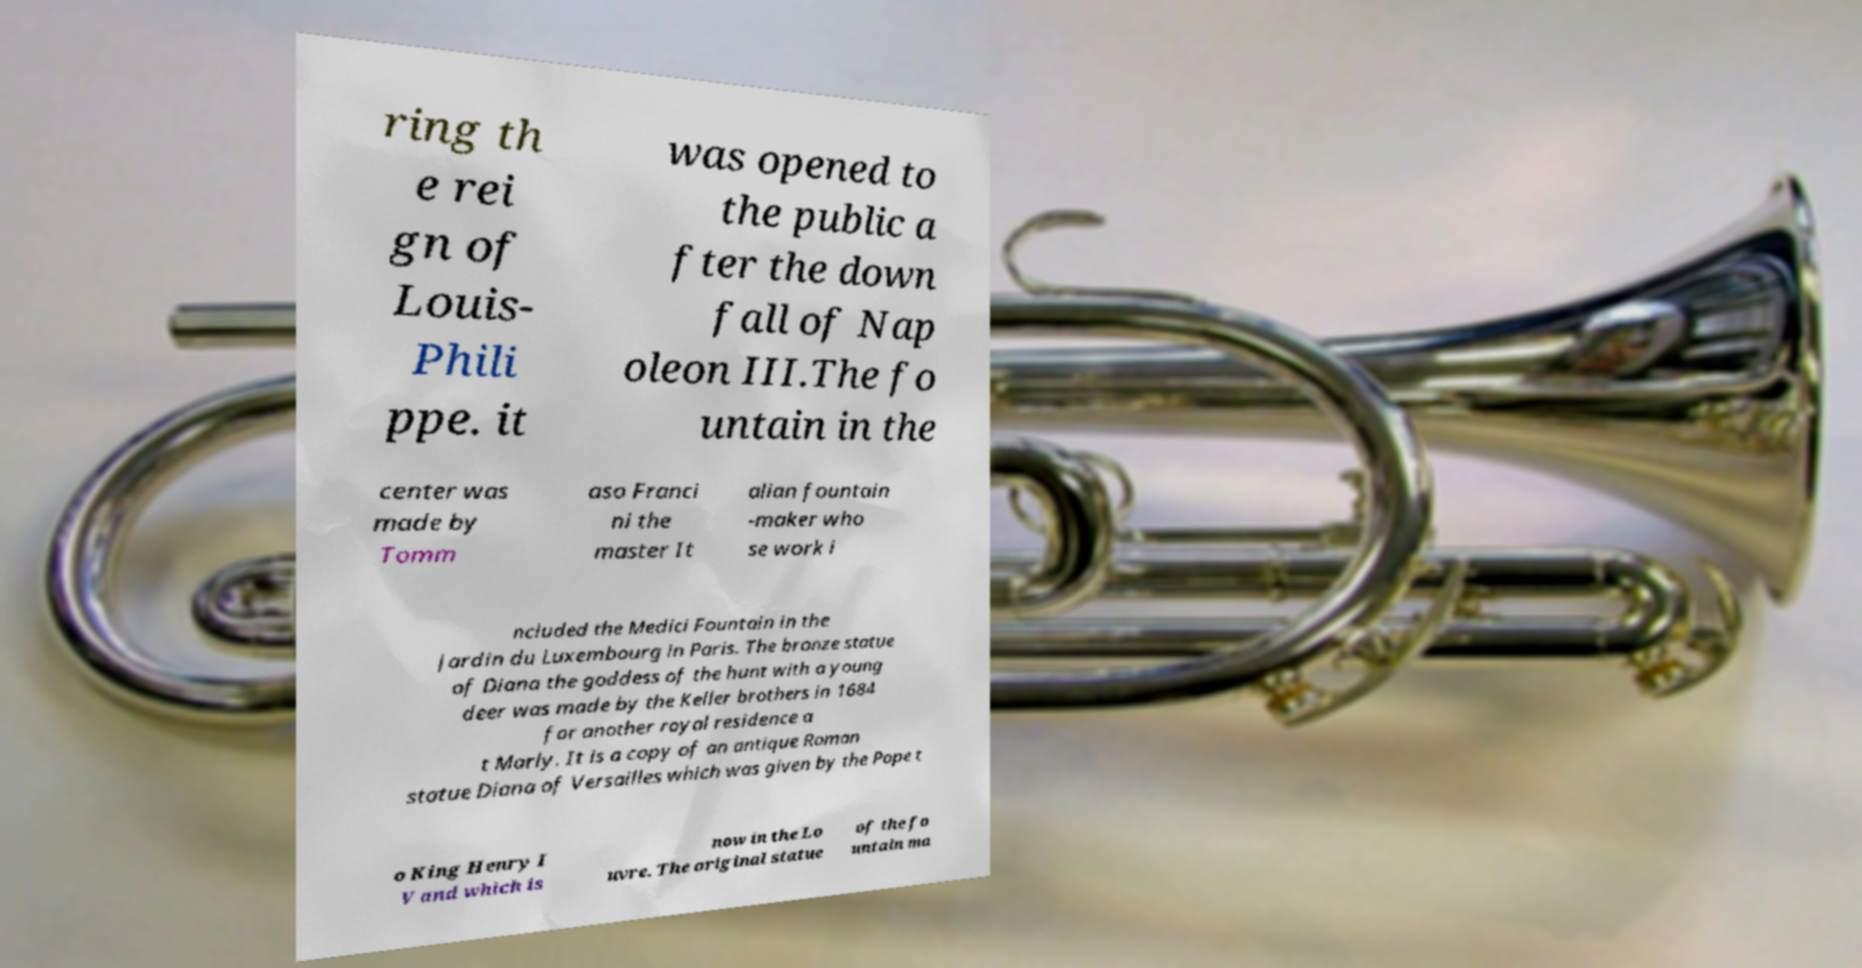Could you assist in decoding the text presented in this image and type it out clearly? ring th e rei gn of Louis- Phili ppe. it was opened to the public a fter the down fall of Nap oleon III.The fo untain in the center was made by Tomm aso Franci ni the master It alian fountain -maker who se work i ncluded the Medici Fountain in the Jardin du Luxembourg in Paris. The bronze statue of Diana the goddess of the hunt with a young deer was made by the Keller brothers in 1684 for another royal residence a t Marly. It is a copy of an antique Roman statue Diana of Versailles which was given by the Pope t o King Henry I V and which is now in the Lo uvre. The original statue of the fo untain ma 